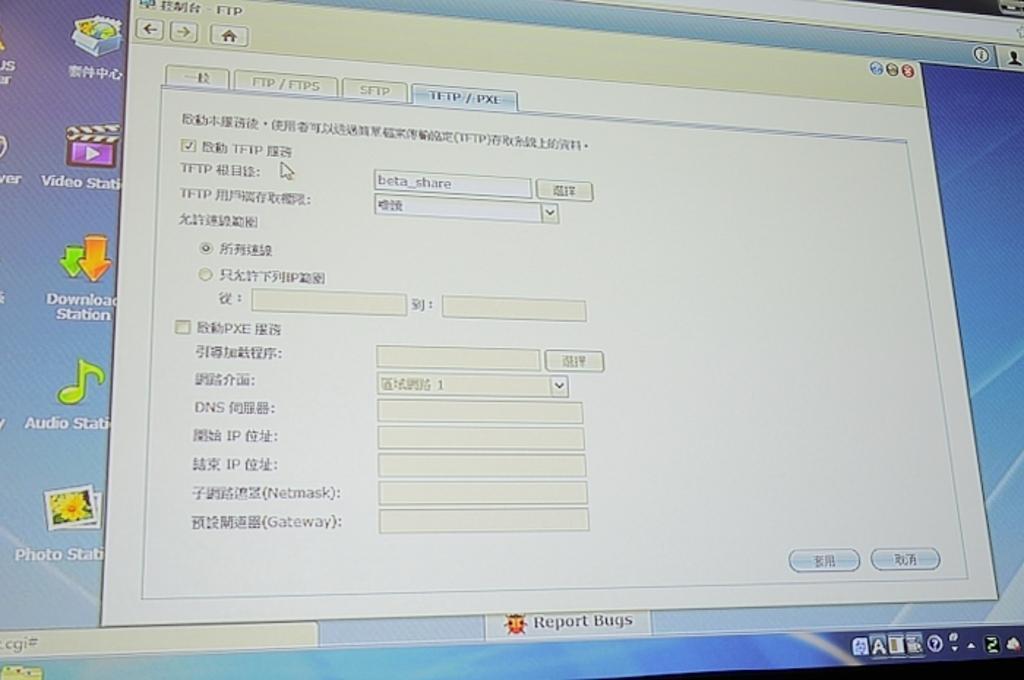Can you describe this image briefly? This image looks like a computer screen. This image is taken, maybe in a room. 